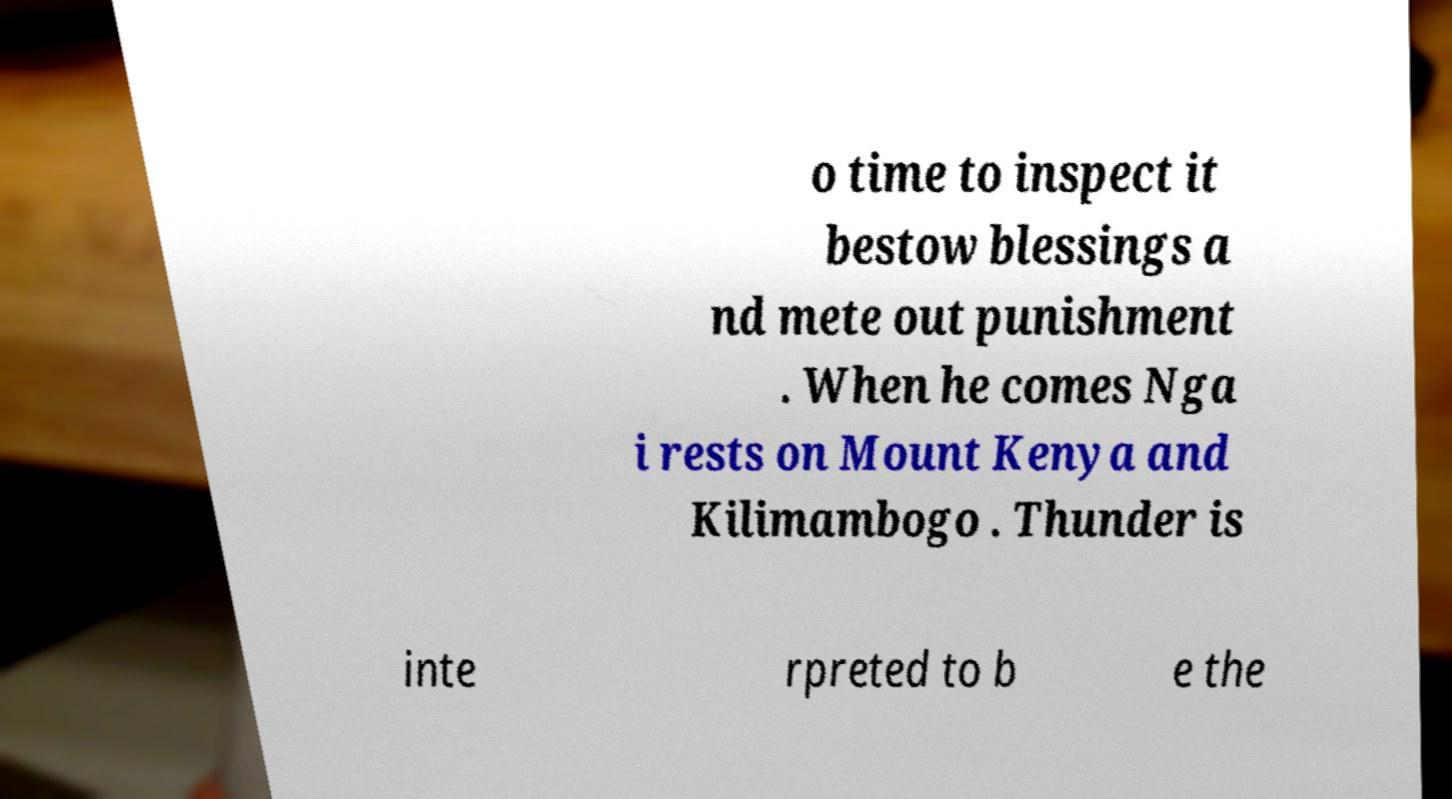Can you accurately transcribe the text from the provided image for me? o time to inspect it bestow blessings a nd mete out punishment . When he comes Nga i rests on Mount Kenya and Kilimambogo . Thunder is inte rpreted to b e the 